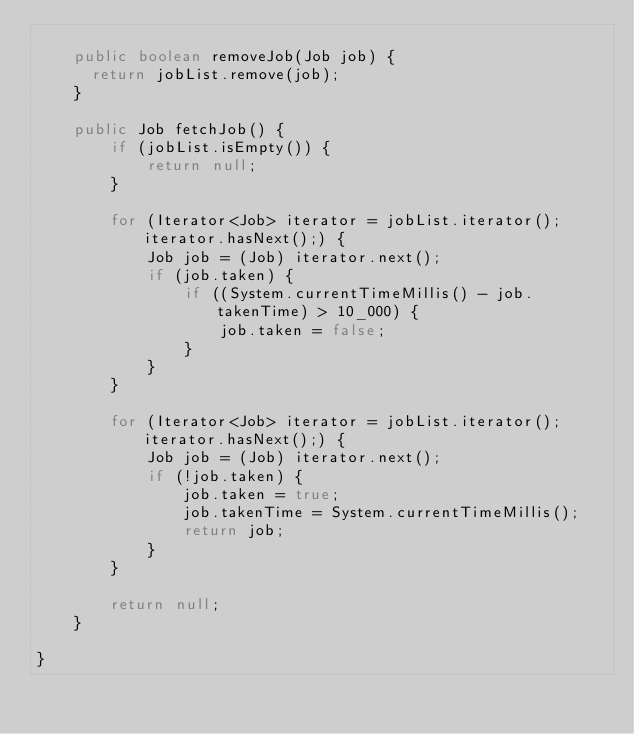<code> <loc_0><loc_0><loc_500><loc_500><_Java_>    
    public boolean removeJob(Job job) {
    	return jobList.remove(job);
    }
    
    public Job fetchJob() {
        if (jobList.isEmpty()) {
            return null;
        }
        
        for (Iterator<Job> iterator = jobList.iterator(); iterator.hasNext();) {
            Job job = (Job) iterator.next();
            if (job.taken) {
                if ((System.currentTimeMillis() - job.takenTime) > 10_000) {
                    job.taken = false;
                }
            }
        }
        
        for (Iterator<Job> iterator = jobList.iterator(); iterator.hasNext();) {
            Job job = (Job) iterator.next();
            if (!job.taken) {
                job.taken = true;
                job.takenTime = System.currentTimeMillis();
                return job;
            }
        }
        
        return null;
    }
    
}
</code> 